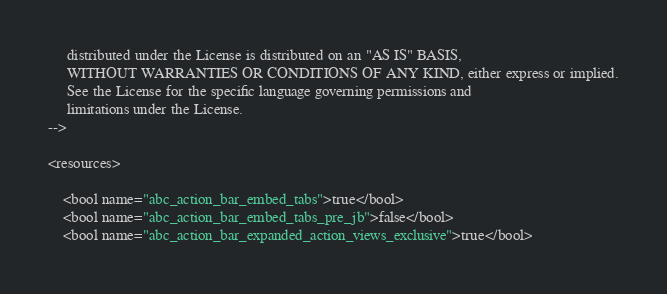Convert code to text. <code><loc_0><loc_0><loc_500><loc_500><_XML_>     distributed under the License is distributed on an "AS IS" BASIS,
     WITHOUT WARRANTIES OR CONDITIONS OF ANY KIND, either express or implied.
     See the License for the specific language governing permissions and
     limitations under the License.
-->

<resources>

    <bool name="abc_action_bar_embed_tabs">true</bool>
    <bool name="abc_action_bar_embed_tabs_pre_jb">false</bool>
    <bool name="abc_action_bar_expanded_action_views_exclusive">true</bool>
</code> 